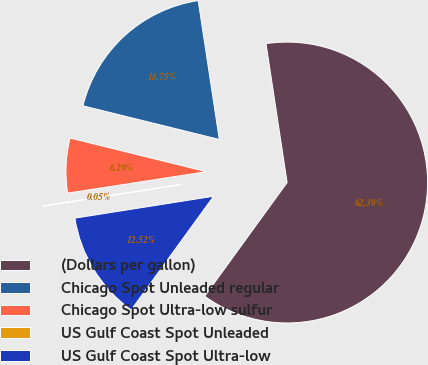<chart> <loc_0><loc_0><loc_500><loc_500><pie_chart><fcel>(Dollars per gallon)<fcel>Chicago Spot Unleaded regular<fcel>Chicago Spot Ultra-low sulfur<fcel>US Gulf Coast Spot Unleaded<fcel>US Gulf Coast Spot Ultra-low<nl><fcel>62.39%<fcel>18.75%<fcel>6.29%<fcel>0.05%<fcel>12.52%<nl></chart> 